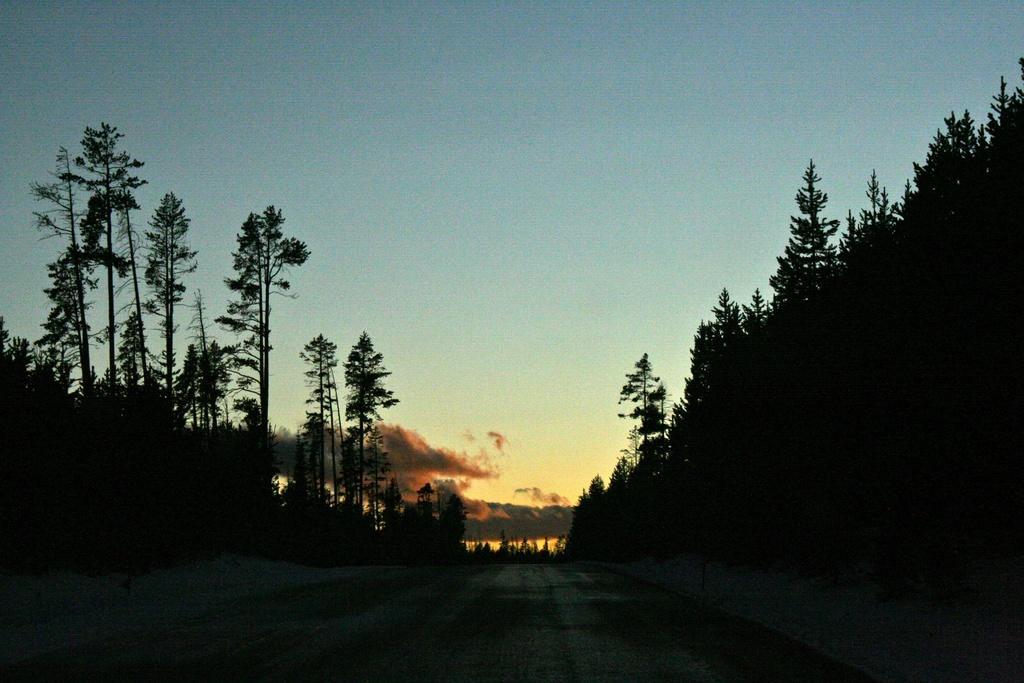How would you summarize this image in a sentence or two? In the foreground of this image, there is a road. On either side, there are trees and at the top, there is the sky. 